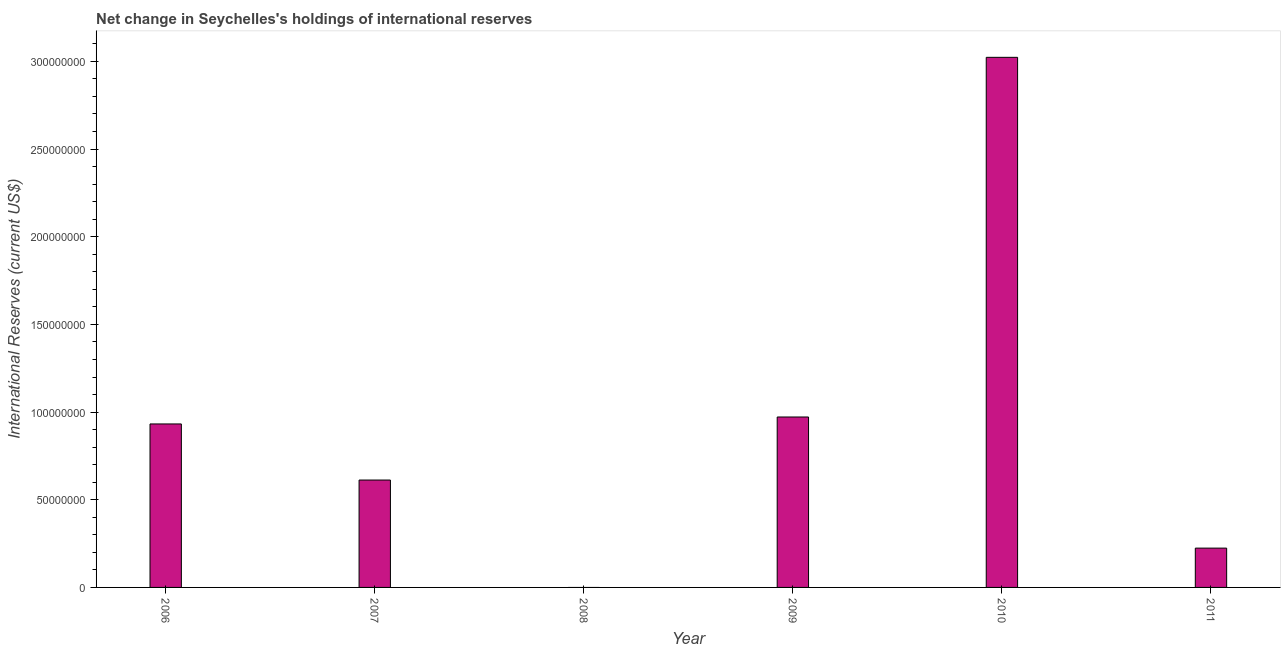What is the title of the graph?
Provide a succinct answer. Net change in Seychelles's holdings of international reserves. What is the label or title of the X-axis?
Ensure brevity in your answer.  Year. What is the label or title of the Y-axis?
Give a very brief answer. International Reserves (current US$). What is the reserves and related items in 2010?
Make the answer very short. 3.02e+08. Across all years, what is the maximum reserves and related items?
Make the answer very short. 3.02e+08. In which year was the reserves and related items maximum?
Your answer should be very brief. 2010. What is the sum of the reserves and related items?
Your answer should be compact. 5.76e+08. What is the difference between the reserves and related items in 2010 and 2011?
Offer a very short reply. 2.80e+08. What is the average reserves and related items per year?
Your answer should be compact. 9.61e+07. What is the median reserves and related items?
Provide a succinct answer. 7.72e+07. What is the ratio of the reserves and related items in 2006 to that in 2011?
Offer a terse response. 4.16. Is the reserves and related items in 2009 less than that in 2011?
Offer a terse response. No. What is the difference between the highest and the second highest reserves and related items?
Provide a succinct answer. 2.05e+08. What is the difference between the highest and the lowest reserves and related items?
Your response must be concise. 3.02e+08. In how many years, is the reserves and related items greater than the average reserves and related items taken over all years?
Provide a succinct answer. 2. How many bars are there?
Your response must be concise. 5. What is the difference between two consecutive major ticks on the Y-axis?
Provide a short and direct response. 5.00e+07. Are the values on the major ticks of Y-axis written in scientific E-notation?
Your answer should be very brief. No. What is the International Reserves (current US$) in 2006?
Keep it short and to the point. 9.32e+07. What is the International Reserves (current US$) in 2007?
Offer a very short reply. 6.12e+07. What is the International Reserves (current US$) of 2009?
Give a very brief answer. 9.72e+07. What is the International Reserves (current US$) of 2010?
Provide a succinct answer. 3.02e+08. What is the International Reserves (current US$) in 2011?
Your response must be concise. 2.24e+07. What is the difference between the International Reserves (current US$) in 2006 and 2007?
Provide a short and direct response. 3.20e+07. What is the difference between the International Reserves (current US$) in 2006 and 2009?
Ensure brevity in your answer.  -3.97e+06. What is the difference between the International Reserves (current US$) in 2006 and 2010?
Make the answer very short. -2.09e+08. What is the difference between the International Reserves (current US$) in 2006 and 2011?
Your response must be concise. 7.08e+07. What is the difference between the International Reserves (current US$) in 2007 and 2009?
Ensure brevity in your answer.  -3.60e+07. What is the difference between the International Reserves (current US$) in 2007 and 2010?
Provide a succinct answer. -2.41e+08. What is the difference between the International Reserves (current US$) in 2007 and 2011?
Your answer should be compact. 3.88e+07. What is the difference between the International Reserves (current US$) in 2009 and 2010?
Your answer should be compact. -2.05e+08. What is the difference between the International Reserves (current US$) in 2009 and 2011?
Your answer should be very brief. 7.48e+07. What is the difference between the International Reserves (current US$) in 2010 and 2011?
Offer a terse response. 2.80e+08. What is the ratio of the International Reserves (current US$) in 2006 to that in 2007?
Ensure brevity in your answer.  1.52. What is the ratio of the International Reserves (current US$) in 2006 to that in 2010?
Your answer should be compact. 0.31. What is the ratio of the International Reserves (current US$) in 2006 to that in 2011?
Ensure brevity in your answer.  4.16. What is the ratio of the International Reserves (current US$) in 2007 to that in 2009?
Your answer should be very brief. 0.63. What is the ratio of the International Reserves (current US$) in 2007 to that in 2010?
Provide a short and direct response. 0.2. What is the ratio of the International Reserves (current US$) in 2007 to that in 2011?
Provide a succinct answer. 2.73. What is the ratio of the International Reserves (current US$) in 2009 to that in 2010?
Offer a terse response. 0.32. What is the ratio of the International Reserves (current US$) in 2009 to that in 2011?
Give a very brief answer. 4.33. What is the ratio of the International Reserves (current US$) in 2010 to that in 2011?
Your response must be concise. 13.48. 